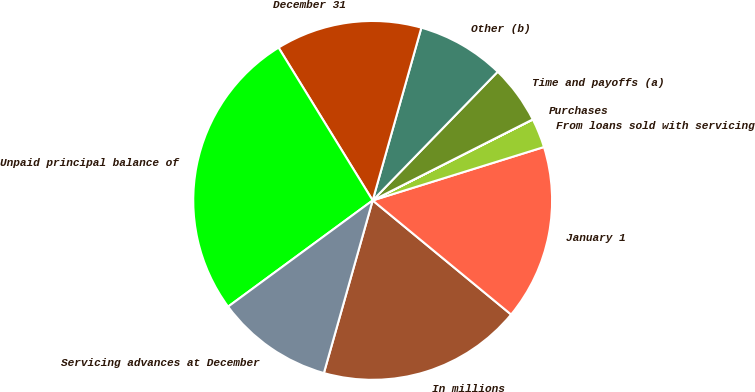Convert chart to OTSL. <chart><loc_0><loc_0><loc_500><loc_500><pie_chart><fcel>In millions<fcel>January 1<fcel>From loans sold with servicing<fcel>Purchases<fcel>Time and payoffs (a)<fcel>Other (b)<fcel>December 31<fcel>Unpaid principal balance of<fcel>Servicing advances at December<nl><fcel>18.41%<fcel>15.78%<fcel>2.64%<fcel>0.01%<fcel>5.27%<fcel>7.9%<fcel>13.16%<fcel>26.3%<fcel>10.53%<nl></chart> 